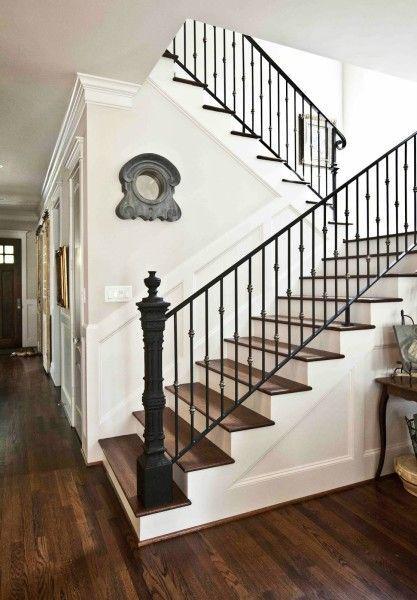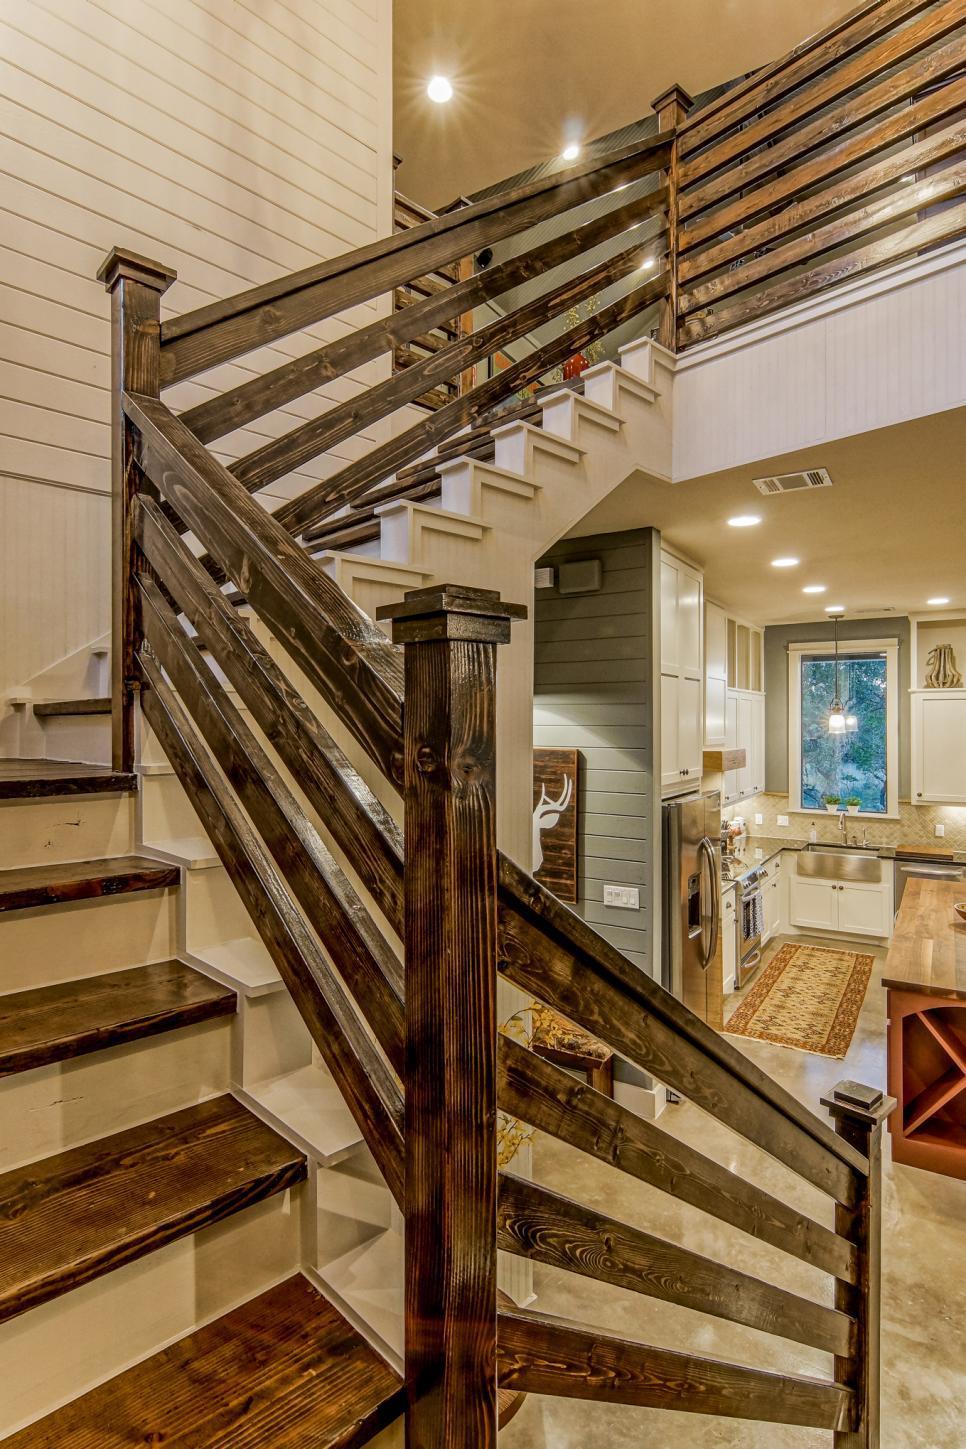The first image is the image on the left, the second image is the image on the right. For the images displayed, is the sentence "The left image shows a leftward-ascending staircase with a square light-colored wood-grain post at the bottom." factually correct? Answer yes or no. No. The first image is the image on the left, the second image is the image on the right. Analyze the images presented: Is the assertion "One of the stair's bannisters ends in a large, light brown colored wooden post." valid? Answer yes or no. No. 